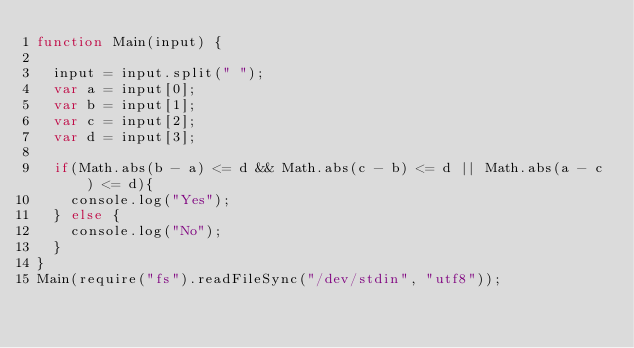Convert code to text. <code><loc_0><loc_0><loc_500><loc_500><_JavaScript_>function Main(input) {

	input = input.split(" ");
	var a = input[0];
	var b = input[1];
	var c = input[2];
	var d = input[3];

	if(Math.abs(b - a) <= d && Math.abs(c - b) <= d || Math.abs(a - c) <= d){
		console.log("Yes");
	} else {
		console.log("No");
	}
}
Main(require("fs").readFileSync("/dev/stdin", "utf8"));
</code> 